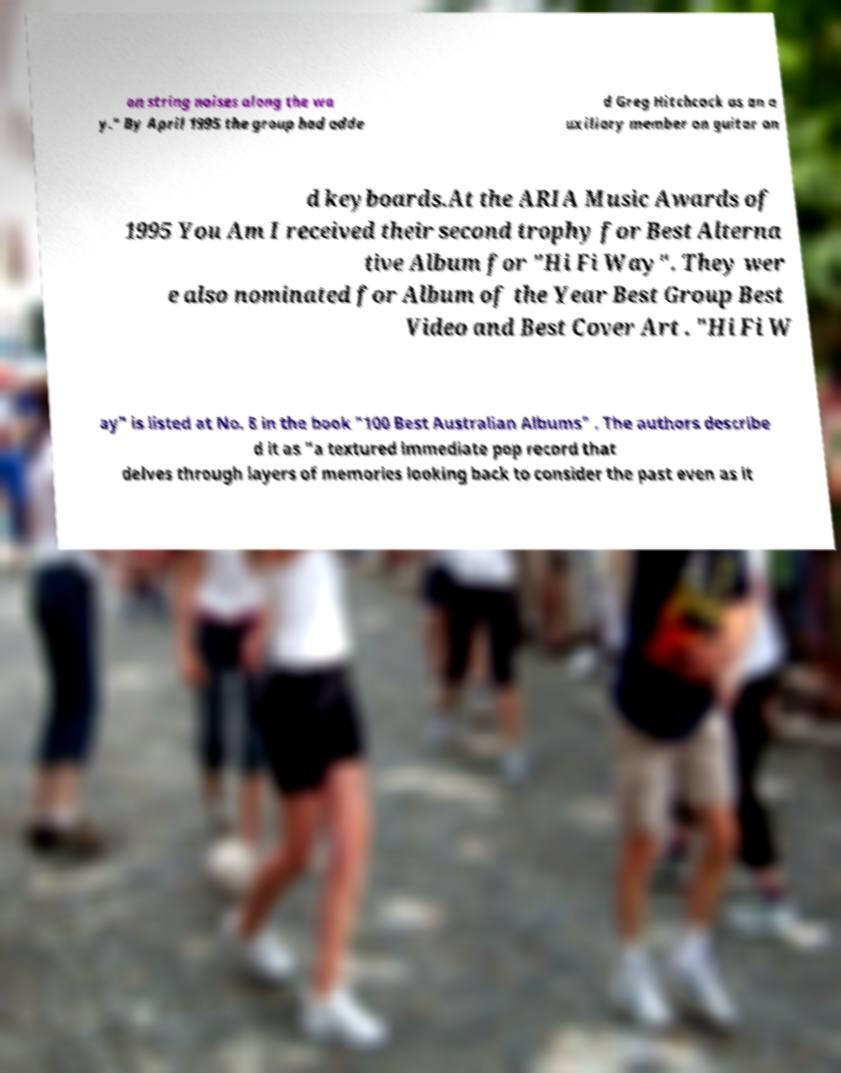I need the written content from this picture converted into text. Can you do that? on string noises along the wa y." By April 1995 the group had adde d Greg Hitchcock as an a uxiliary member on guitar an d keyboards.At the ARIA Music Awards of 1995 You Am I received their second trophy for Best Alterna tive Album for "Hi Fi Way". They wer e also nominated for Album of the Year Best Group Best Video and Best Cover Art . "Hi Fi W ay" is listed at No. 8 in the book "100 Best Australian Albums" . The authors describe d it as "a textured immediate pop record that delves through layers of memories looking back to consider the past even as it 